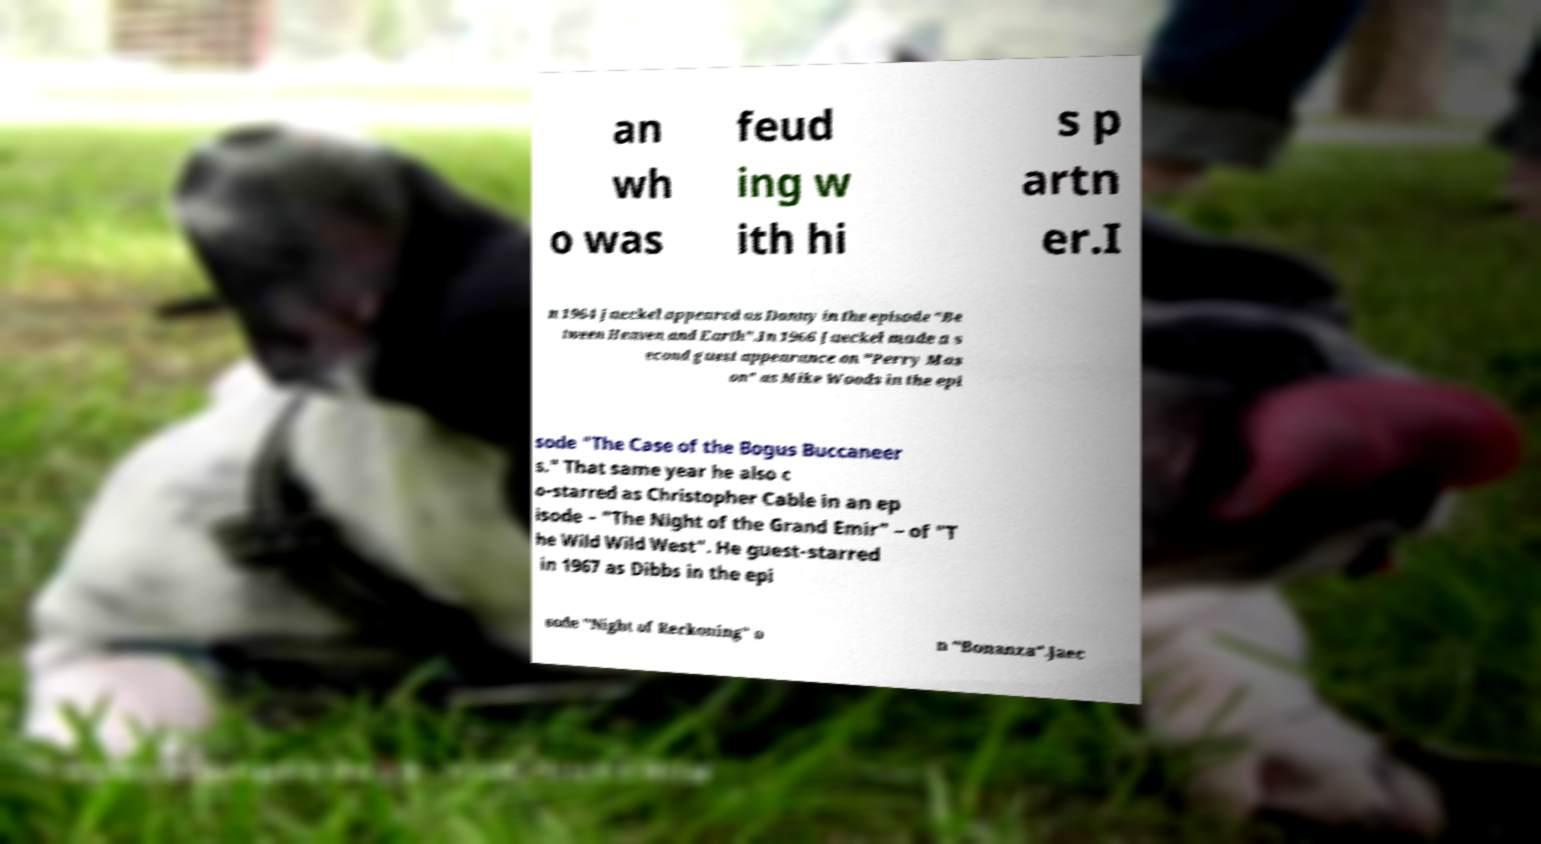What messages or text are displayed in this image? I need them in a readable, typed format. an wh o was feud ing w ith hi s p artn er.I n 1964 Jaeckel appeared as Danny in the episode ″Be tween Heaven and Earth″.In 1966 Jaeckel made a s econd guest appearance on "Perry Mas on" as Mike Woods in the epi sode "The Case of the Bogus Buccaneer s." That same year he also c o-starred as Christopher Cable in an ep isode – "The Night of the Grand Emir" – of "T he Wild Wild West". He guest-starred in 1967 as Dibbs in the epi sode "Night of Reckoning" o n "Bonanza".Jaec 